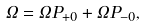Convert formula to latex. <formula><loc_0><loc_0><loc_500><loc_500>\Omega = \Omega P _ { + 0 } + \Omega P _ { - 0 } ,</formula> 